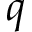<formula> <loc_0><loc_0><loc_500><loc_500>q</formula> 